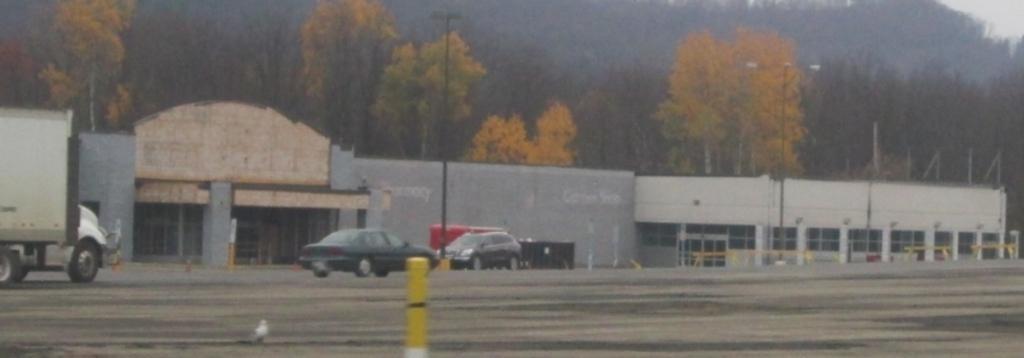Describe this image in one or two sentences. In this image we can see vehicles on the road, poles and light poles. In the background there are buildings, poles, trees, doors and sky. 